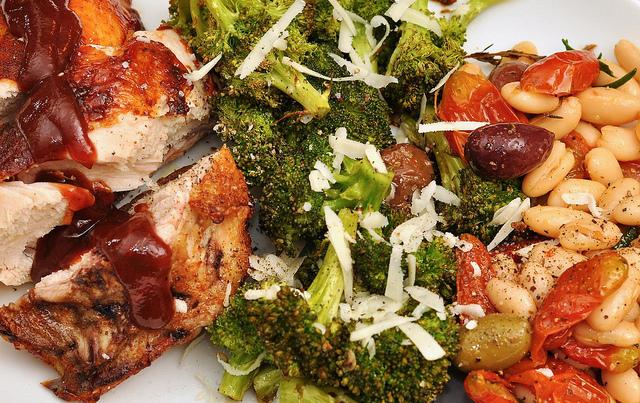What are they having for dinner?
Be succinct. Chicken, broccoli and beans. Is that broccoli?
Short answer required. Yes. How many different foods are on the plate?
Quick response, please. 3. 